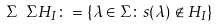<formula> <loc_0><loc_0><loc_500><loc_500>\Sigma \ \Sigma H _ { I } \colon = \{ \lambda \in \Sigma \colon s ( \lambda ) \not \in H _ { I } \}</formula> 